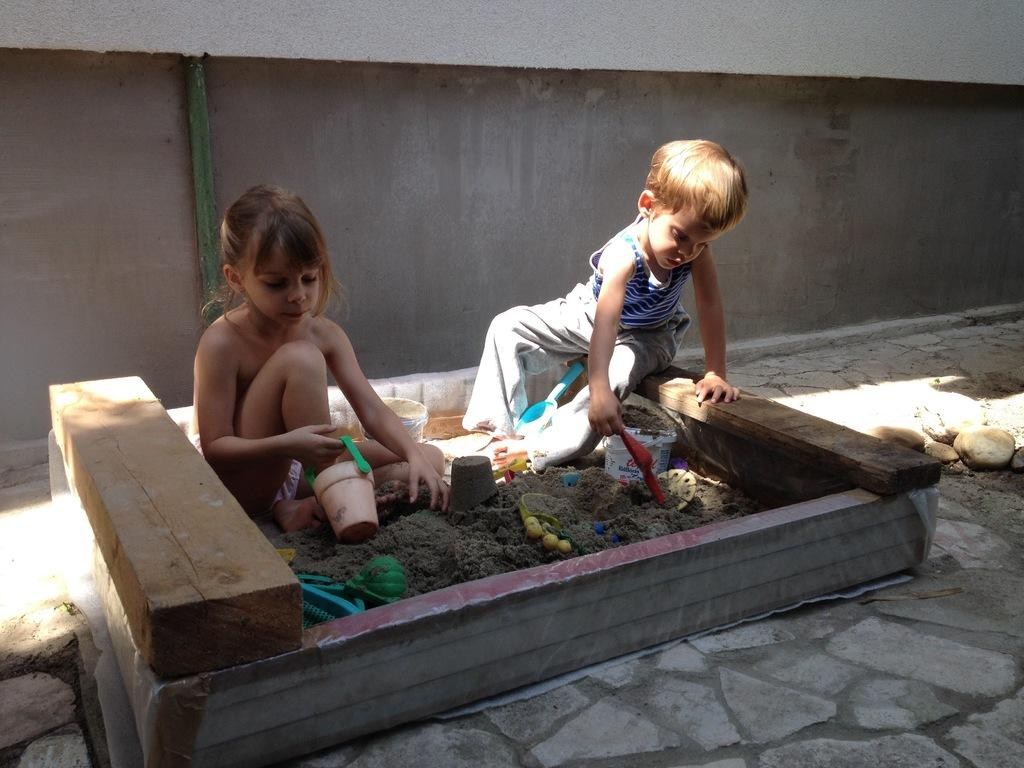What are the children doing in the image? The children are playing with mud in the image. What else can be seen in the image besides the children playing with mud? There are toys in the image. What can be seen in the background of the image? There is a wall in the background of the image. What type of fruit is being used to build the cart in the image? There is no cart or fruit present in the image; the children are playing with mud and there are toys visible. 